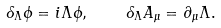Convert formula to latex. <formula><loc_0><loc_0><loc_500><loc_500>\delta _ { \Lambda } \phi = i \Lambda \phi , \quad \delta _ { \Lambda } A _ { \mu } = \partial _ { \mu } \Lambda .</formula> 